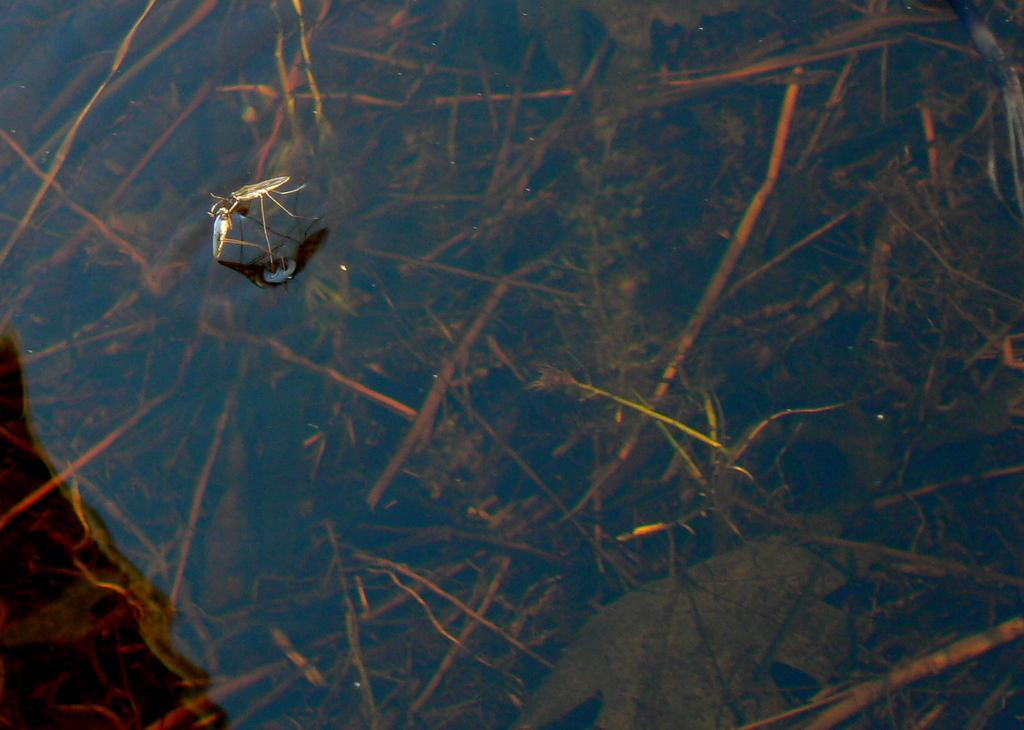Describe this image in one or two sentences. In this image we can see insect in a water. In the background we can see water. 